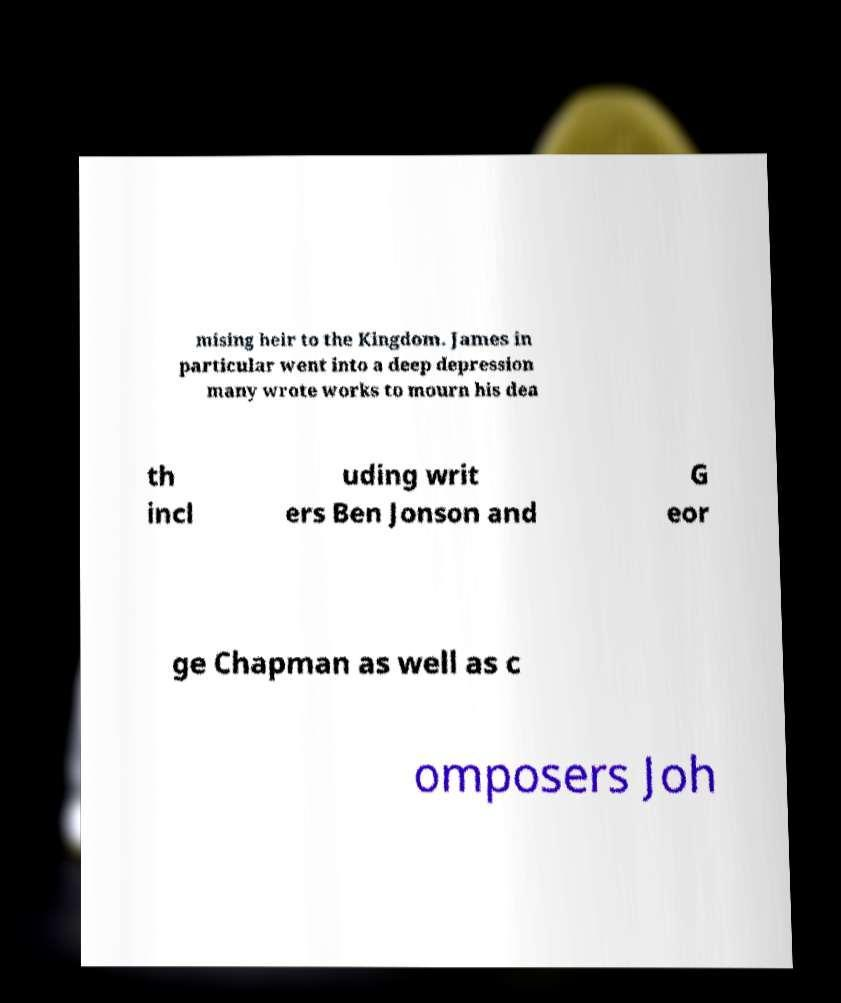I need the written content from this picture converted into text. Can you do that? mising heir to the Kingdom. James in particular went into a deep depression many wrote works to mourn his dea th incl uding writ ers Ben Jonson and G eor ge Chapman as well as c omposers Joh 